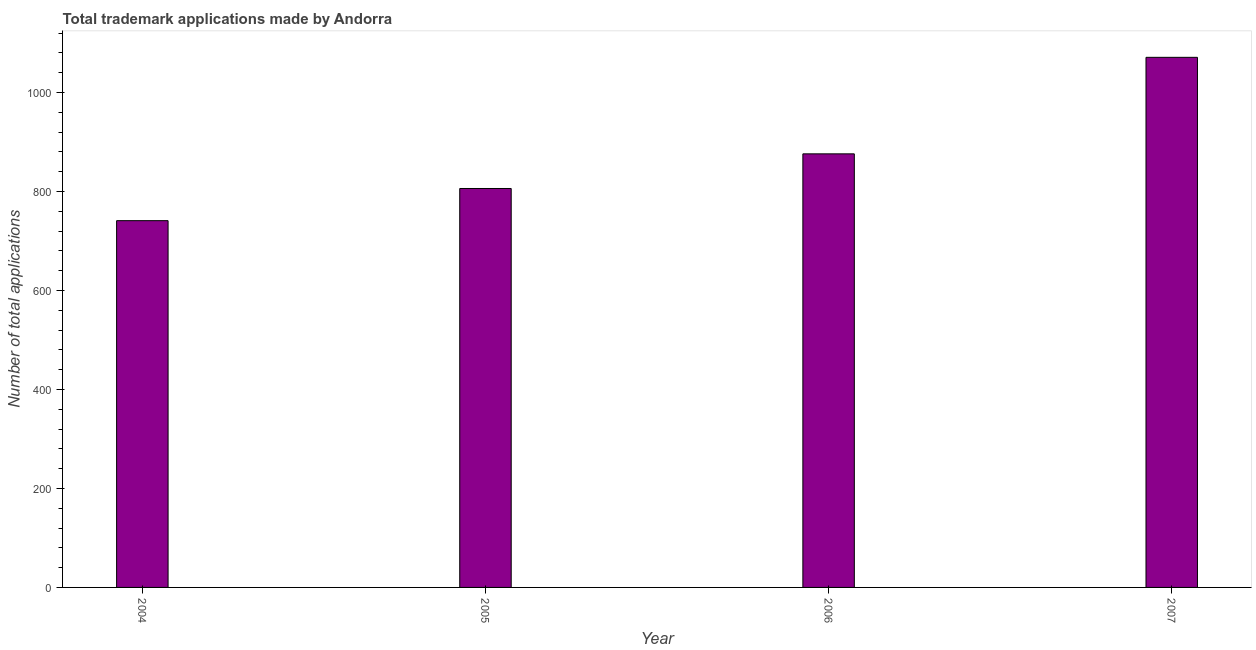Does the graph contain grids?
Your answer should be very brief. No. What is the title of the graph?
Your answer should be compact. Total trademark applications made by Andorra. What is the label or title of the X-axis?
Offer a terse response. Year. What is the label or title of the Y-axis?
Ensure brevity in your answer.  Number of total applications. What is the number of trademark applications in 2007?
Ensure brevity in your answer.  1071. Across all years, what is the maximum number of trademark applications?
Give a very brief answer. 1071. Across all years, what is the minimum number of trademark applications?
Give a very brief answer. 741. In which year was the number of trademark applications minimum?
Ensure brevity in your answer.  2004. What is the sum of the number of trademark applications?
Offer a very short reply. 3494. What is the difference between the number of trademark applications in 2005 and 2007?
Offer a very short reply. -265. What is the average number of trademark applications per year?
Ensure brevity in your answer.  873. What is the median number of trademark applications?
Provide a succinct answer. 841. In how many years, is the number of trademark applications greater than 840 ?
Your response must be concise. 2. Do a majority of the years between 2007 and 2005 (inclusive) have number of trademark applications greater than 800 ?
Make the answer very short. Yes. What is the ratio of the number of trademark applications in 2004 to that in 2005?
Provide a short and direct response. 0.92. What is the difference between the highest and the second highest number of trademark applications?
Provide a short and direct response. 195. Is the sum of the number of trademark applications in 2004 and 2006 greater than the maximum number of trademark applications across all years?
Your answer should be compact. Yes. What is the difference between the highest and the lowest number of trademark applications?
Your answer should be compact. 330. How many years are there in the graph?
Your response must be concise. 4. What is the difference between two consecutive major ticks on the Y-axis?
Make the answer very short. 200. What is the Number of total applications in 2004?
Your answer should be very brief. 741. What is the Number of total applications of 2005?
Your answer should be compact. 806. What is the Number of total applications of 2006?
Keep it short and to the point. 876. What is the Number of total applications in 2007?
Provide a short and direct response. 1071. What is the difference between the Number of total applications in 2004 and 2005?
Your answer should be very brief. -65. What is the difference between the Number of total applications in 2004 and 2006?
Offer a terse response. -135. What is the difference between the Number of total applications in 2004 and 2007?
Your answer should be compact. -330. What is the difference between the Number of total applications in 2005 and 2006?
Your answer should be very brief. -70. What is the difference between the Number of total applications in 2005 and 2007?
Give a very brief answer. -265. What is the difference between the Number of total applications in 2006 and 2007?
Make the answer very short. -195. What is the ratio of the Number of total applications in 2004 to that in 2005?
Give a very brief answer. 0.92. What is the ratio of the Number of total applications in 2004 to that in 2006?
Offer a terse response. 0.85. What is the ratio of the Number of total applications in 2004 to that in 2007?
Provide a succinct answer. 0.69. What is the ratio of the Number of total applications in 2005 to that in 2007?
Make the answer very short. 0.75. What is the ratio of the Number of total applications in 2006 to that in 2007?
Keep it short and to the point. 0.82. 